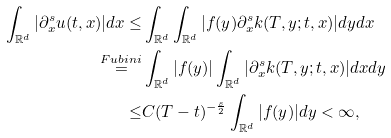<formula> <loc_0><loc_0><loc_500><loc_500>\int _ { \mathbb { R } ^ { d } } | \partial _ { x } ^ { s } u ( t , x ) | d x \leq & \int _ { \mathbb { R } ^ { d } } \int _ { \mathbb { R } ^ { d } } | f ( y ) \partial _ { x } ^ { s } k ( T , y ; t , x ) | d y d x \\ \overset { F u b i n i } = & \int _ { \mathbb { R } ^ { d } } | f ( y ) | \int _ { \mathbb { R } ^ { d } } | \partial _ { x } ^ { s } k ( T , y ; t , x ) | d x d y \\ \leq & C ( T - t ) ^ { - \frac { s } { 2 } } \int _ { \mathbb { R } ^ { d } } | f ( y ) | d y < \infty ,</formula> 